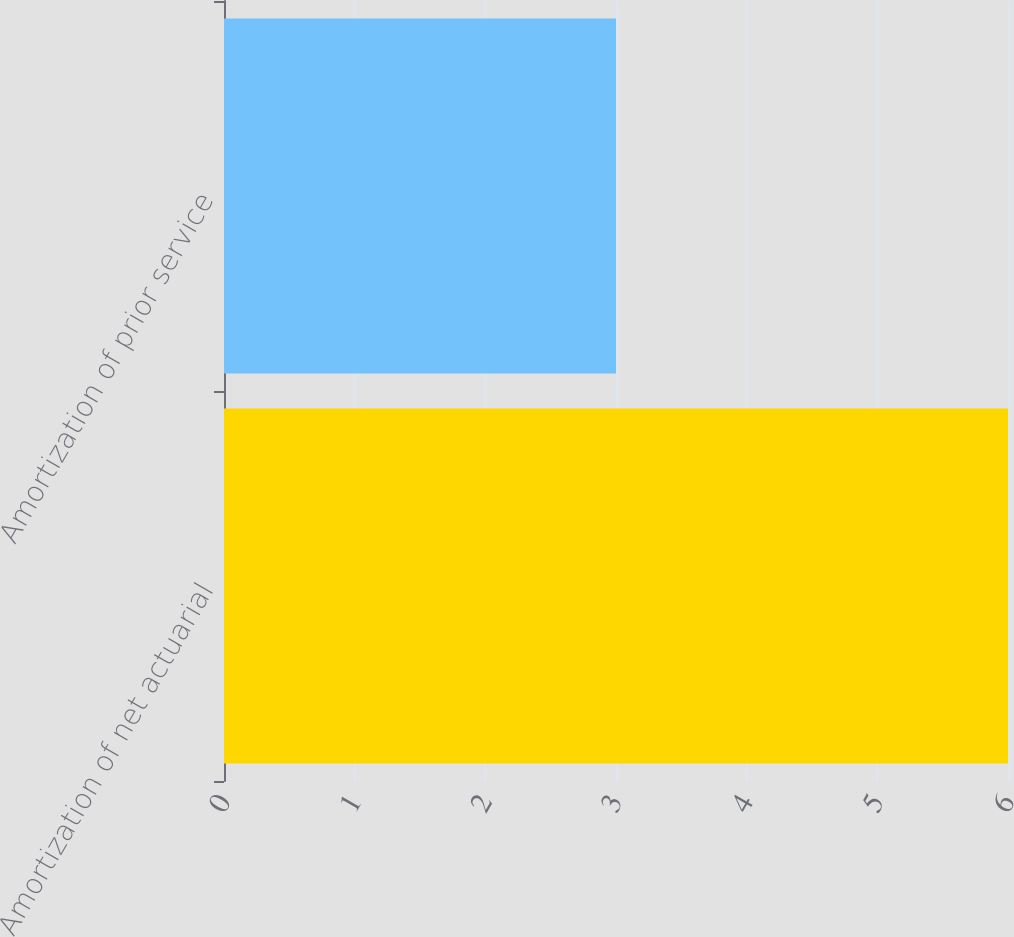Convert chart. <chart><loc_0><loc_0><loc_500><loc_500><bar_chart><fcel>Amortization of net actuarial<fcel>Amortization of prior service<nl><fcel>6<fcel>3<nl></chart> 